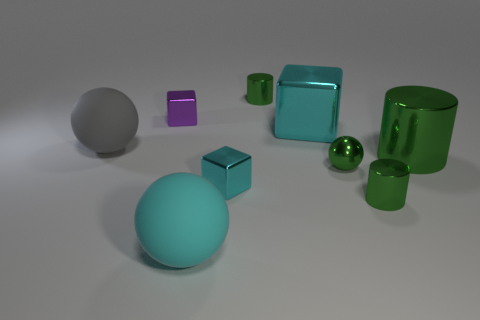Can you describe the lighting and shadows visible in the scene? The lighting in the image seems to come from above, casting soft, diffused shadows that gently stretch away from the objects. The shadows are subtle and help define the three-dimensional forms of the shapes by providing a sense of depth and position within the scene. 